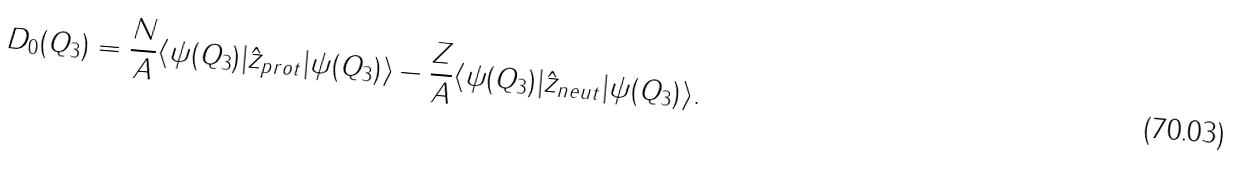Convert formula to latex. <formula><loc_0><loc_0><loc_500><loc_500>D _ { 0 } ( Q _ { 3 } ) = \frac { N } { A } \langle \psi ( Q _ { 3 } ) | \hat { z } _ { p r o t } | \psi ( Q _ { 3 } ) \rangle - \frac { Z } { A } \langle \psi ( Q _ { 3 } ) | \hat { z } _ { n e u t } | \psi ( Q _ { 3 } ) \rangle .</formula> 